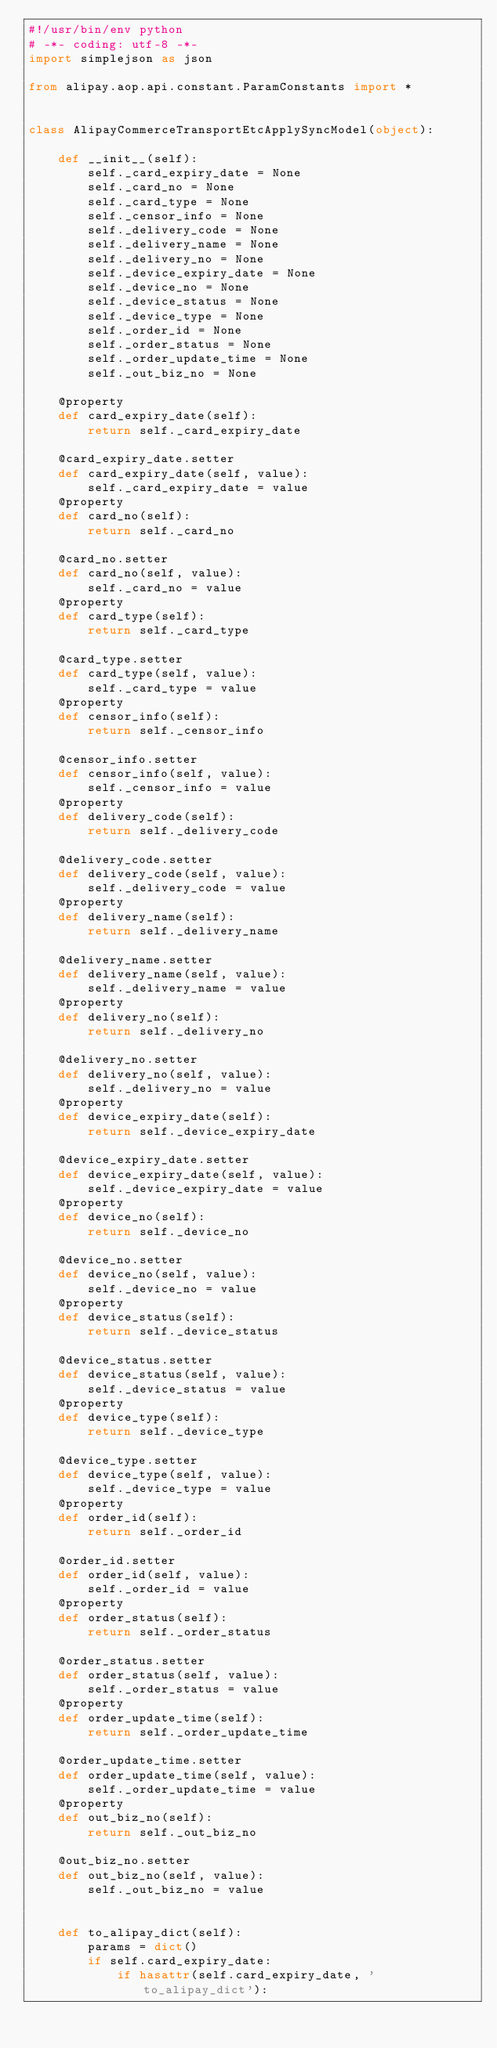<code> <loc_0><loc_0><loc_500><loc_500><_Python_>#!/usr/bin/env python
# -*- coding: utf-8 -*-
import simplejson as json

from alipay.aop.api.constant.ParamConstants import *


class AlipayCommerceTransportEtcApplySyncModel(object):

    def __init__(self):
        self._card_expiry_date = None
        self._card_no = None
        self._card_type = None
        self._censor_info = None
        self._delivery_code = None
        self._delivery_name = None
        self._delivery_no = None
        self._device_expiry_date = None
        self._device_no = None
        self._device_status = None
        self._device_type = None
        self._order_id = None
        self._order_status = None
        self._order_update_time = None
        self._out_biz_no = None

    @property
    def card_expiry_date(self):
        return self._card_expiry_date

    @card_expiry_date.setter
    def card_expiry_date(self, value):
        self._card_expiry_date = value
    @property
    def card_no(self):
        return self._card_no

    @card_no.setter
    def card_no(self, value):
        self._card_no = value
    @property
    def card_type(self):
        return self._card_type

    @card_type.setter
    def card_type(self, value):
        self._card_type = value
    @property
    def censor_info(self):
        return self._censor_info

    @censor_info.setter
    def censor_info(self, value):
        self._censor_info = value
    @property
    def delivery_code(self):
        return self._delivery_code

    @delivery_code.setter
    def delivery_code(self, value):
        self._delivery_code = value
    @property
    def delivery_name(self):
        return self._delivery_name

    @delivery_name.setter
    def delivery_name(self, value):
        self._delivery_name = value
    @property
    def delivery_no(self):
        return self._delivery_no

    @delivery_no.setter
    def delivery_no(self, value):
        self._delivery_no = value
    @property
    def device_expiry_date(self):
        return self._device_expiry_date

    @device_expiry_date.setter
    def device_expiry_date(self, value):
        self._device_expiry_date = value
    @property
    def device_no(self):
        return self._device_no

    @device_no.setter
    def device_no(self, value):
        self._device_no = value
    @property
    def device_status(self):
        return self._device_status

    @device_status.setter
    def device_status(self, value):
        self._device_status = value
    @property
    def device_type(self):
        return self._device_type

    @device_type.setter
    def device_type(self, value):
        self._device_type = value
    @property
    def order_id(self):
        return self._order_id

    @order_id.setter
    def order_id(self, value):
        self._order_id = value
    @property
    def order_status(self):
        return self._order_status

    @order_status.setter
    def order_status(self, value):
        self._order_status = value
    @property
    def order_update_time(self):
        return self._order_update_time

    @order_update_time.setter
    def order_update_time(self, value):
        self._order_update_time = value
    @property
    def out_biz_no(self):
        return self._out_biz_no

    @out_biz_no.setter
    def out_biz_no(self, value):
        self._out_biz_no = value


    def to_alipay_dict(self):
        params = dict()
        if self.card_expiry_date:
            if hasattr(self.card_expiry_date, 'to_alipay_dict'):</code> 